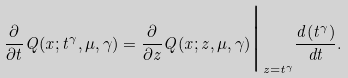<formula> <loc_0><loc_0><loc_500><loc_500>\frac { \partial } { \partial t } Q ( x ; t ^ { \gamma } , \mu , \gamma ) = \frac { \partial } { \partial z } Q ( x ; z , \mu , \gamma ) \Big | _ { z = t ^ { \gamma } } \frac { d ( t ^ { \gamma } ) } { d t } .</formula> 